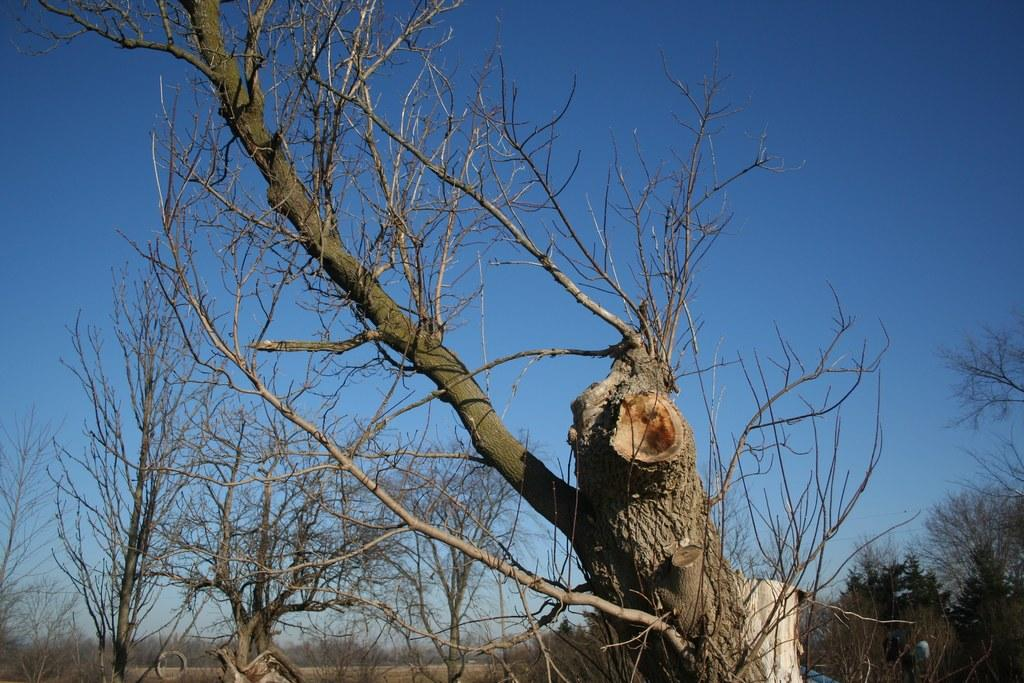What type of vegetation can be seen in the image? There are dried trees in the image. What is visible in the background of the image? The sky is visible in the background of the image. What color is the sky in the image? The color of the sky is blue. What type of shirt is the toad wearing in the image? There is no toad or shirt present in the image. What discovery was made while observing the image? There is no discovery mentioned or implied in the image. 